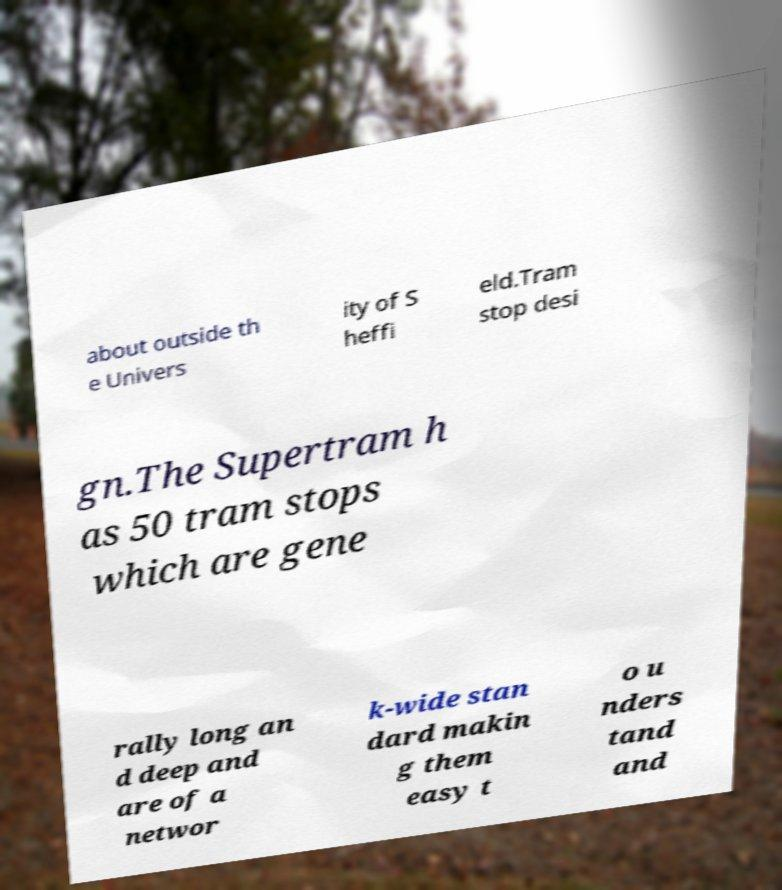There's text embedded in this image that I need extracted. Can you transcribe it verbatim? about outside th e Univers ity of S heffi eld.Tram stop desi gn.The Supertram h as 50 tram stops which are gene rally long an d deep and are of a networ k-wide stan dard makin g them easy t o u nders tand and 